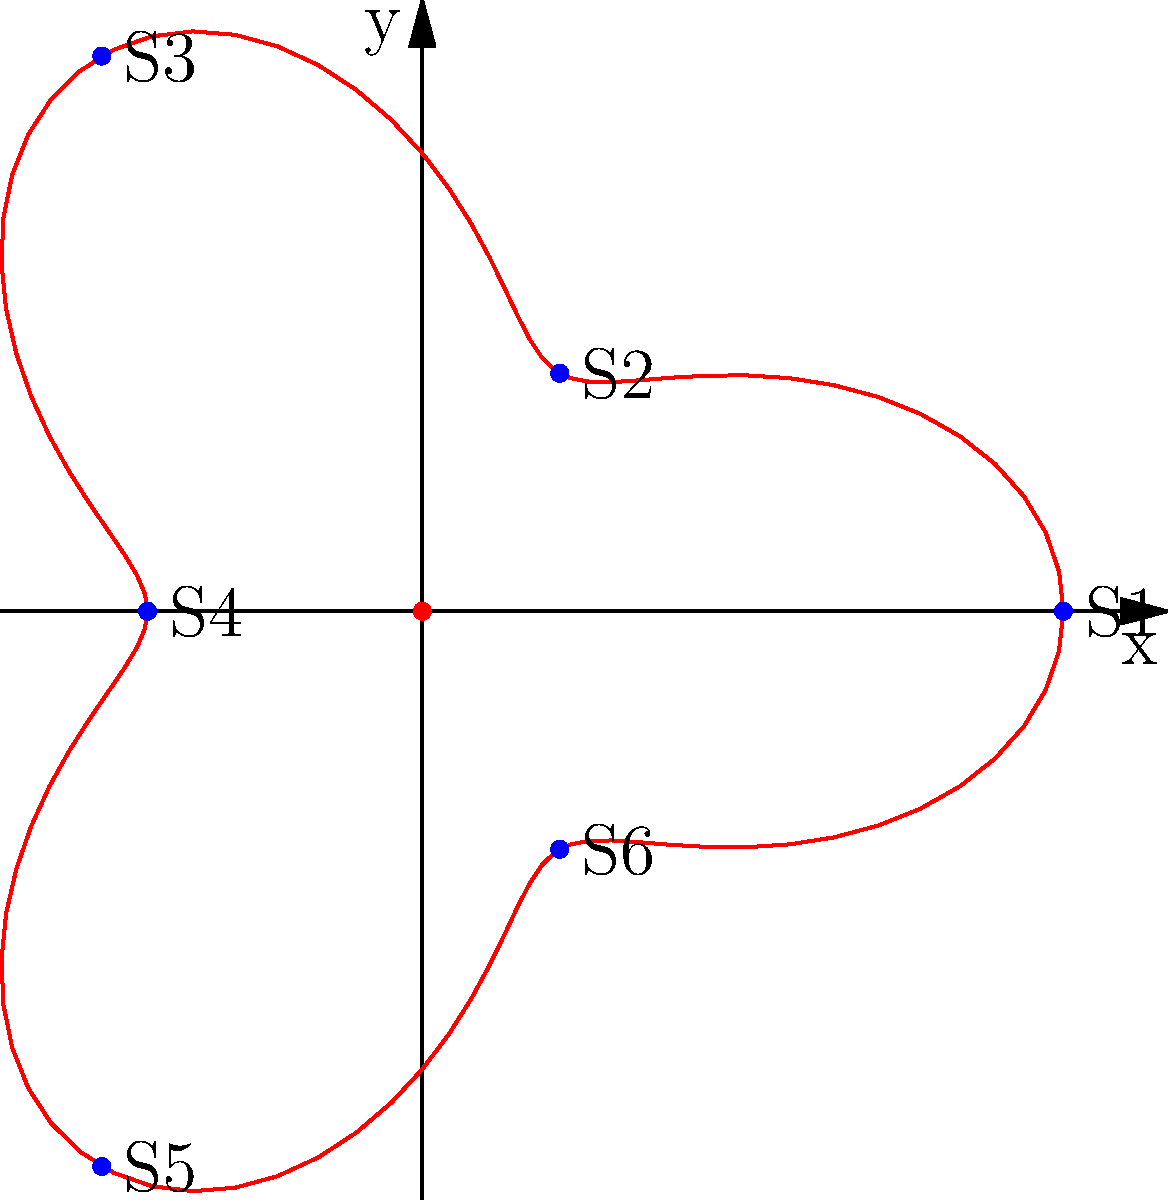In a traditional Middle Eastern bazaar, six stalls (S1 to S6) are arranged along a spiral path described by the polar equation $r = 5 + 2\cos(3\theta)$, where $r$ is in meters. If a customer wants to walk from stall S1 to stall S4, what is the shortest distance between these two stalls, rounded to the nearest tenth of a meter? To solve this problem, we'll follow these steps:

1) First, we need to determine the coordinates of stalls S1 and S4.

2) S1 is at $\theta = 0$:
   $r_1 = 5 + 2\cos(3 \cdot 0) = 7$
   $(x_1, y_1) = (7\cos(0), 7\sin(0)) = (7, 0)$

3) S4 is at $\theta = \pi$:
   $r_4 = 5 + 2\cos(3\pi) = 5 + 2 = 7$
   $(x_4, y_4) = (7\cos(\pi), 7\sin(\pi)) = (-7, 0)$

4) The shortest distance between two points is a straight line. We can calculate this using the distance formula:

   $d = \sqrt{(x_2-x_1)^2 + (y_2-y_1)^2}$

5) Plugging in our values:
   $d = \sqrt{(-7-7)^2 + (0-0)^2} = \sqrt{(-14)^2 + 0^2} = \sqrt{196} = 14$

6) Rounding to the nearest tenth:
   $14.0$ meters
Answer: 14.0 meters 